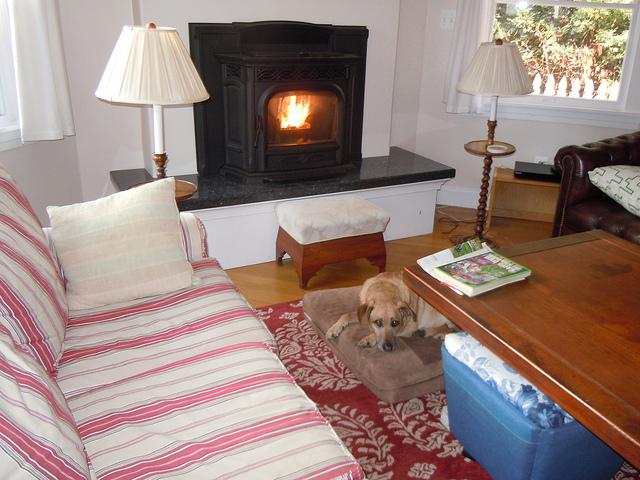Is there a fire in the fireplace?
Be succinct. Yes. Is it daytime?
Answer briefly. Yes. Does the dog look sad?
Answer briefly. Yes. 